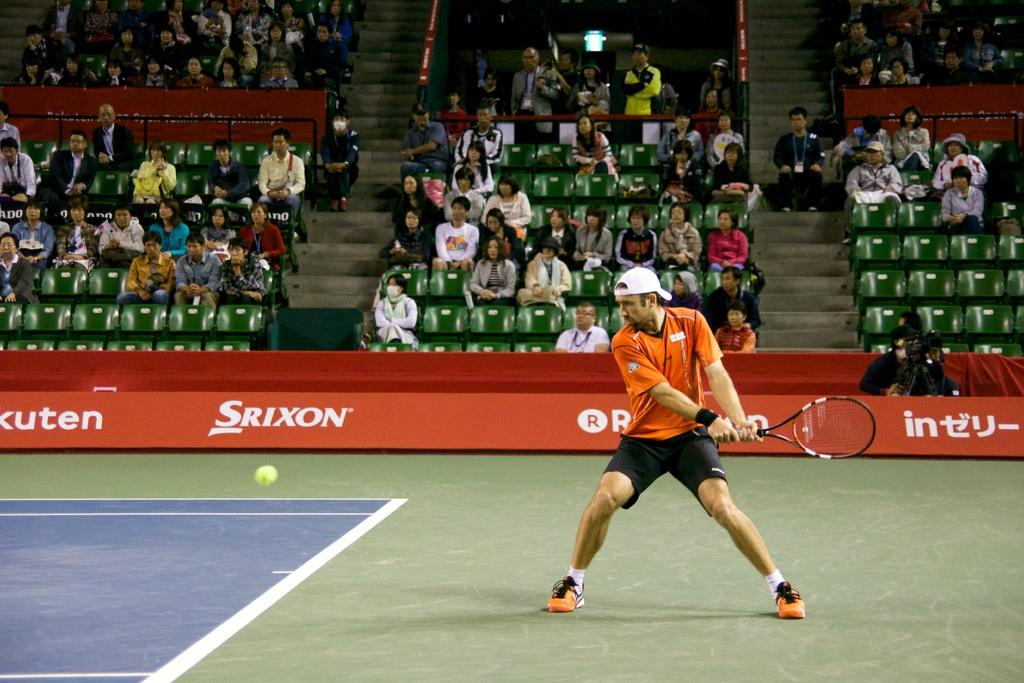<image>
Present a compact description of the photo's key features. A tennis player on a court with a Srixon advertisement on the wall in the background. 